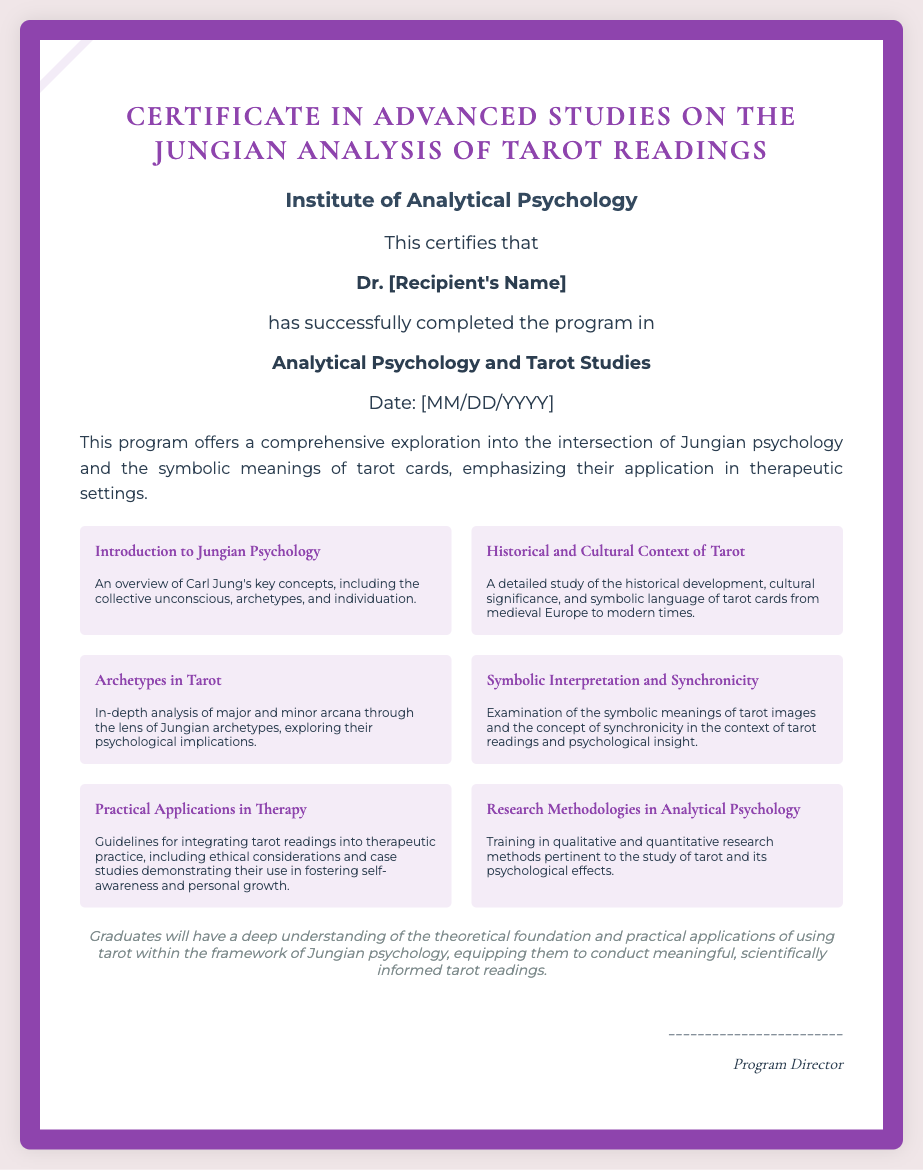What is the name of the certificate program? The name of the certificate program is stated clearly at the top of the document.
Answer: Certificate in Advanced Studies on the Jungian Analysis of Tarot Readings Who issued the certificate? The institution that issued the certificate is mentioned just below the program name.
Answer: Institute of Analytical Psychology Who is the recipient of the certificate? The specific individual who received the certificate is highlighted in bold within the document.
Answer: Dr. [Recipient's Name] What is the date format used in the certificate? The date format is specified under the date heading.
Answer: [MM/DD/YYYY] What is one of the modules listed in the program? Several modules are listed, and one can be extracted from the modules section.
Answer: Introduction to Jungian Psychology What is the main focus of the program described? The description outlines the comprehensive exploration undertaken in the course.
Answer: Intersection of Jungian psychology and the symbolic meanings of tarot cards What key concept is emphasized in practical applications? The practical applications section suggests a particular focus in therapeutic practice.
Answer: Ethical considerations What kind of research methodologies are included in the program? The document details types of methodologies within the program.
Answer: Qualitative and quantitative research methods What does the outcome statement emphasize for graduates? The outcome section provides an overview of what graduates will understand after completing the program.
Answer: Theoretical foundation and practical applications 